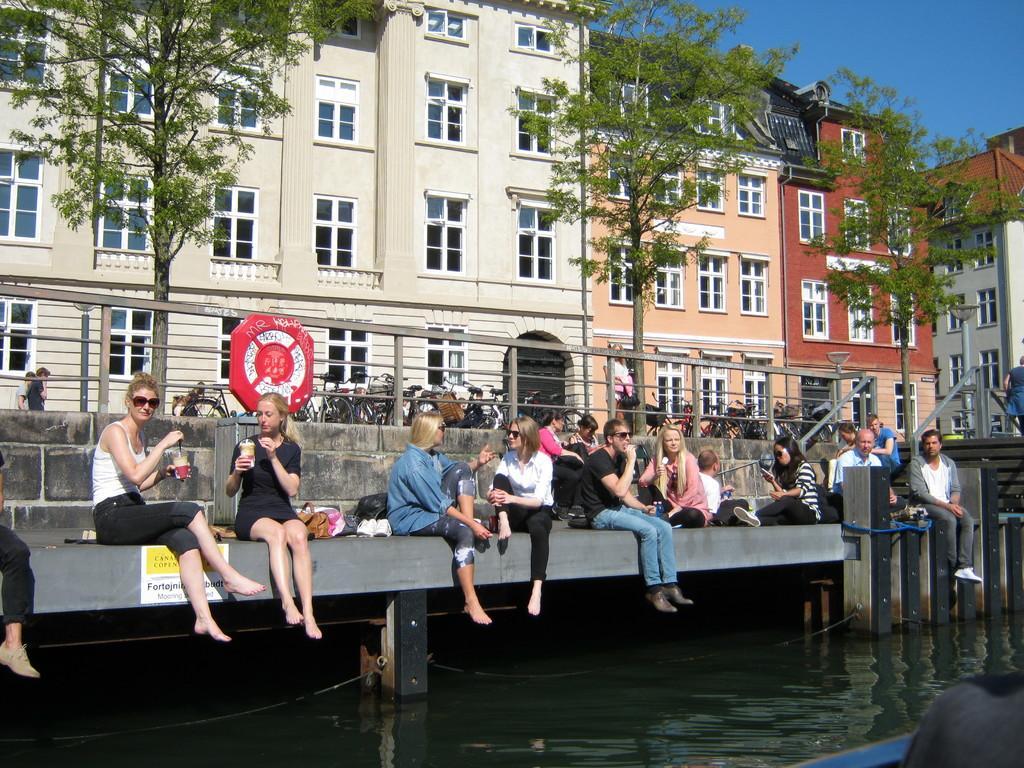In one or two sentences, can you explain what this image depicts? In this image I can see a bridge like thing on which there are some people seating and also I can see a fencing, buildings, trees, vehicles to the other side of the fencing. 